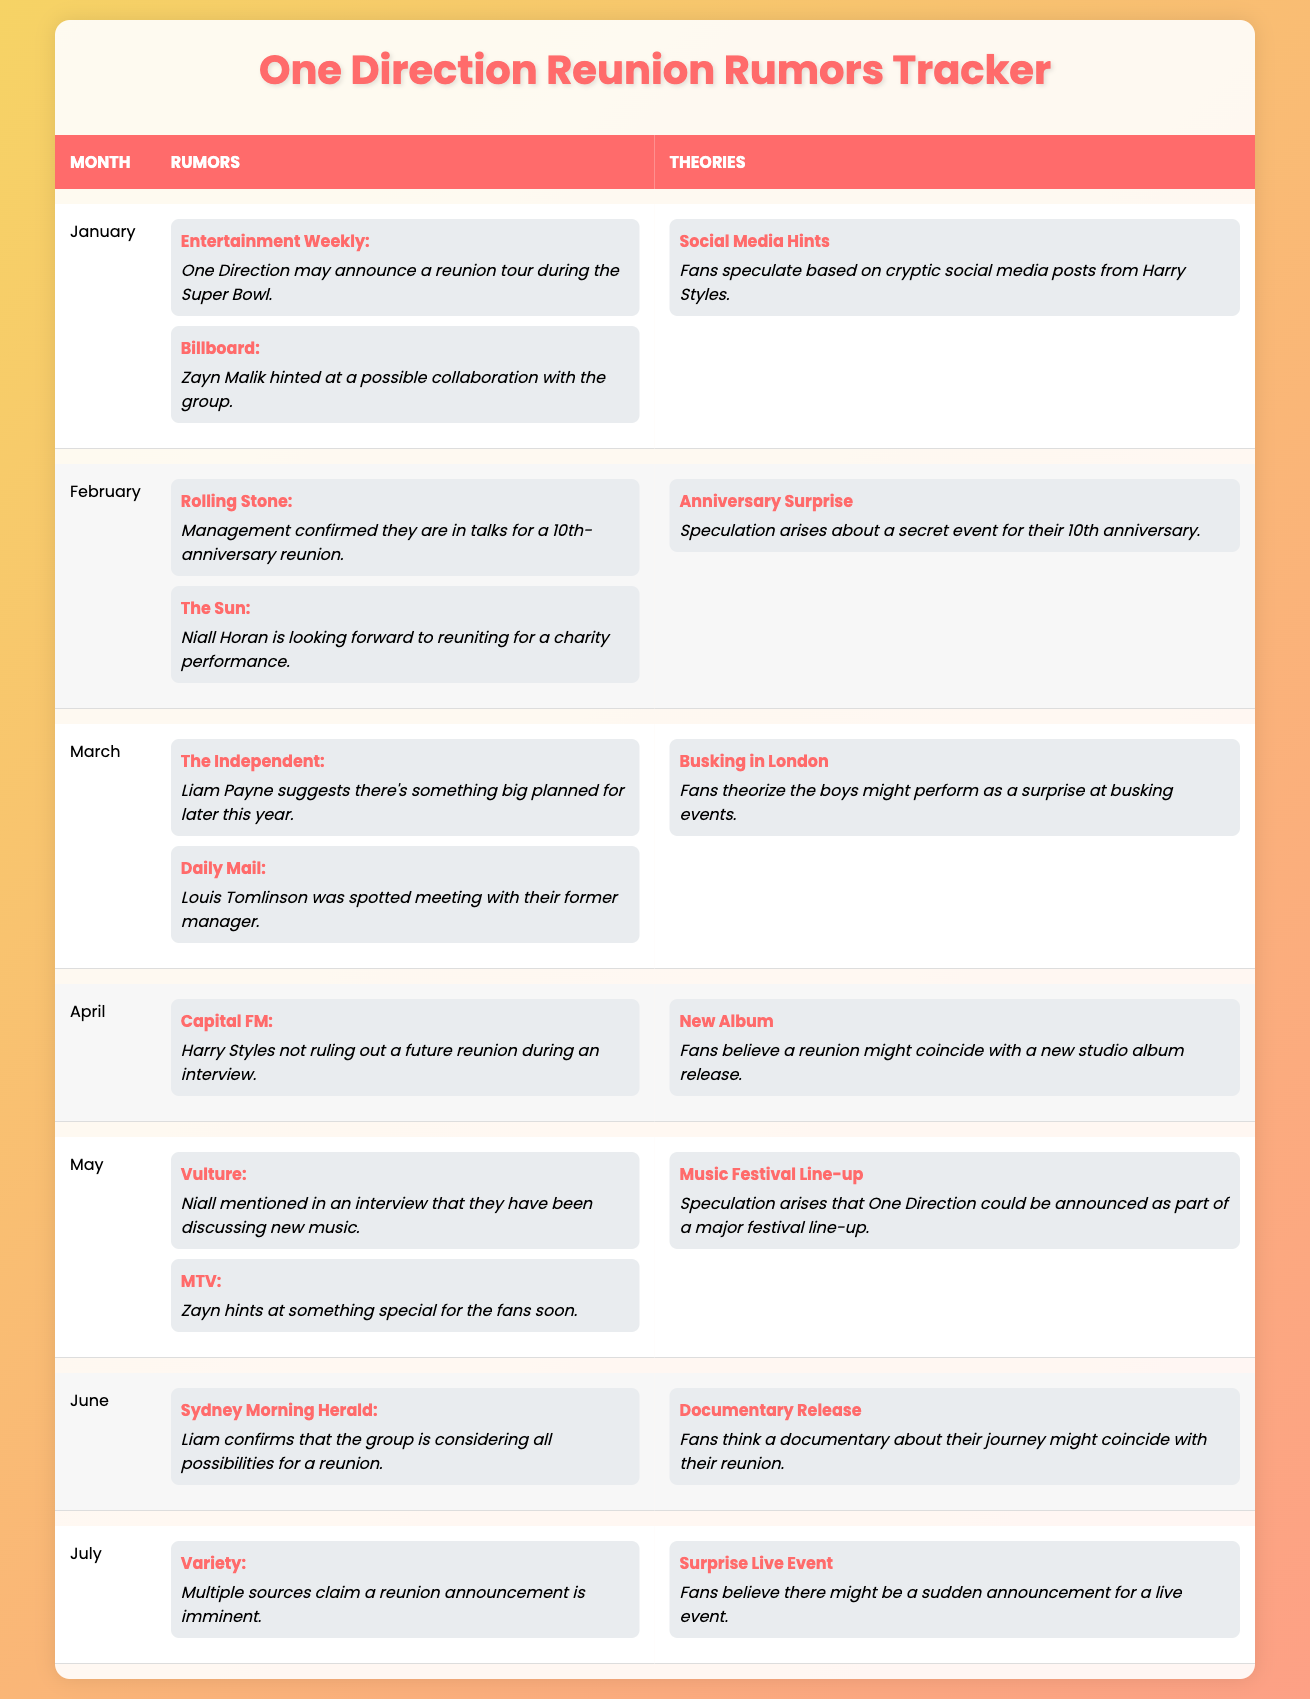What rumor did Billboard report in January? Billboard reported that Zayn Malik hinted at a possible collaboration with the group in January.
Answer: Zayn Malik hinted at a collaboration What theory is associated with the rumors from February? The theory linked to February's rumors is "Anniversary Surprise," which speculates about a secret event for their 10th anniversary.
Answer: Anniversary Surprise How many rumors were discussed in March? There were two rumors discussed in March: one from The Independent and one from Daily Mail.
Answer: 2 Is there any confirmation about a reunion announcement in July? Yes, multiple sources claimed that a reunion announcement is imminent in July.
Answer: Yes What are the two sources of rumors presented in May? The two sources of rumors in May are Vulture and MTV.
Answer: Vulture and MTV Which month had the theory related to a documentary release? The theory related to a documentary release is found in June.
Answer: June In how many months did Niall Horan express something about a reunion? Niall Horan is mentioned in rumors for both February and May, so he expressed something about a reunion in two months.
Answer: 2 What is the relationship between the theories for June and the rumors from earlier months? The theory for June is about a documentary release, which suggests fans believe a film could coincide with a reunion, connecting it to overall reunion discussions throughout the year.
Answer: Documenting the reunion discussion Are there more rumors in April than in January? No, April had one rumor while January had two, thus there are more rumors in January than in April.
Answer: No What do all the theory names present in the table have in common? All the theory names suggest speculations about future events involving One Direction's reunion.
Answer: Speculations about reunion events 